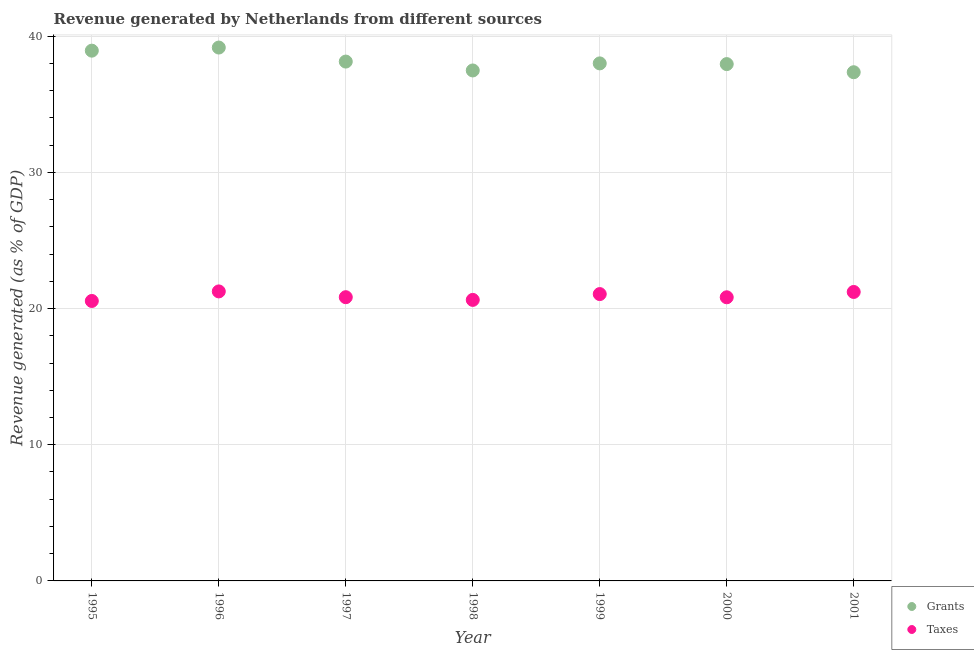Is the number of dotlines equal to the number of legend labels?
Ensure brevity in your answer.  Yes. What is the revenue generated by taxes in 1998?
Your answer should be compact. 20.64. Across all years, what is the maximum revenue generated by grants?
Your response must be concise. 39.17. Across all years, what is the minimum revenue generated by grants?
Keep it short and to the point. 37.36. In which year was the revenue generated by grants maximum?
Offer a very short reply. 1996. In which year was the revenue generated by grants minimum?
Offer a very short reply. 2001. What is the total revenue generated by taxes in the graph?
Offer a terse response. 146.41. What is the difference between the revenue generated by taxes in 1998 and that in 1999?
Ensure brevity in your answer.  -0.43. What is the difference between the revenue generated by grants in 1997 and the revenue generated by taxes in 1998?
Make the answer very short. 17.5. What is the average revenue generated by taxes per year?
Your answer should be compact. 20.92. In the year 1998, what is the difference between the revenue generated by grants and revenue generated by taxes?
Offer a terse response. 16.85. In how many years, is the revenue generated by taxes greater than 10 %?
Offer a very short reply. 7. What is the ratio of the revenue generated by taxes in 1998 to that in 1999?
Offer a very short reply. 0.98. Is the difference between the revenue generated by taxes in 1995 and 2000 greater than the difference between the revenue generated by grants in 1995 and 2000?
Offer a very short reply. No. What is the difference between the highest and the second highest revenue generated by grants?
Your response must be concise. 0.23. What is the difference between the highest and the lowest revenue generated by grants?
Provide a succinct answer. 1.81. Is the sum of the revenue generated by grants in 1998 and 2000 greater than the maximum revenue generated by taxes across all years?
Give a very brief answer. Yes. Does the revenue generated by taxes monotonically increase over the years?
Ensure brevity in your answer.  No. Is the revenue generated by taxes strictly greater than the revenue generated by grants over the years?
Ensure brevity in your answer.  No. Is the revenue generated by grants strictly less than the revenue generated by taxes over the years?
Ensure brevity in your answer.  No. How many dotlines are there?
Offer a very short reply. 2. How many years are there in the graph?
Give a very brief answer. 7. Does the graph contain any zero values?
Offer a terse response. No. Does the graph contain grids?
Your response must be concise. Yes. Where does the legend appear in the graph?
Your answer should be compact. Bottom right. How many legend labels are there?
Ensure brevity in your answer.  2. How are the legend labels stacked?
Offer a terse response. Vertical. What is the title of the graph?
Your answer should be compact. Revenue generated by Netherlands from different sources. Does "Rural Population" appear as one of the legend labels in the graph?
Make the answer very short. No. What is the label or title of the X-axis?
Make the answer very short. Year. What is the label or title of the Y-axis?
Offer a very short reply. Revenue generated (as % of GDP). What is the Revenue generated (as % of GDP) in Grants in 1995?
Your answer should be very brief. 38.94. What is the Revenue generated (as % of GDP) in Taxes in 1995?
Give a very brief answer. 20.56. What is the Revenue generated (as % of GDP) in Grants in 1996?
Keep it short and to the point. 39.17. What is the Revenue generated (as % of GDP) of Taxes in 1996?
Offer a very short reply. 21.26. What is the Revenue generated (as % of GDP) of Grants in 1997?
Give a very brief answer. 38.14. What is the Revenue generated (as % of GDP) in Taxes in 1997?
Ensure brevity in your answer.  20.84. What is the Revenue generated (as % of GDP) in Grants in 1998?
Give a very brief answer. 37.49. What is the Revenue generated (as % of GDP) in Taxes in 1998?
Your answer should be compact. 20.64. What is the Revenue generated (as % of GDP) in Grants in 1999?
Provide a succinct answer. 38.01. What is the Revenue generated (as % of GDP) in Taxes in 1999?
Offer a terse response. 21.07. What is the Revenue generated (as % of GDP) in Grants in 2000?
Your answer should be very brief. 37.95. What is the Revenue generated (as % of GDP) of Taxes in 2000?
Provide a short and direct response. 20.83. What is the Revenue generated (as % of GDP) of Grants in 2001?
Offer a terse response. 37.36. What is the Revenue generated (as % of GDP) of Taxes in 2001?
Make the answer very short. 21.22. Across all years, what is the maximum Revenue generated (as % of GDP) of Grants?
Provide a succinct answer. 39.17. Across all years, what is the maximum Revenue generated (as % of GDP) in Taxes?
Your response must be concise. 21.26. Across all years, what is the minimum Revenue generated (as % of GDP) of Grants?
Keep it short and to the point. 37.36. Across all years, what is the minimum Revenue generated (as % of GDP) of Taxes?
Ensure brevity in your answer.  20.56. What is the total Revenue generated (as % of GDP) of Grants in the graph?
Your answer should be compact. 267.06. What is the total Revenue generated (as % of GDP) in Taxes in the graph?
Provide a short and direct response. 146.41. What is the difference between the Revenue generated (as % of GDP) in Grants in 1995 and that in 1996?
Provide a succinct answer. -0.23. What is the difference between the Revenue generated (as % of GDP) in Taxes in 1995 and that in 1996?
Your answer should be compact. -0.7. What is the difference between the Revenue generated (as % of GDP) in Grants in 1995 and that in 1997?
Keep it short and to the point. 0.8. What is the difference between the Revenue generated (as % of GDP) in Taxes in 1995 and that in 1997?
Provide a succinct answer. -0.28. What is the difference between the Revenue generated (as % of GDP) of Grants in 1995 and that in 1998?
Offer a very short reply. 1.45. What is the difference between the Revenue generated (as % of GDP) in Taxes in 1995 and that in 1998?
Make the answer very short. -0.08. What is the difference between the Revenue generated (as % of GDP) of Grants in 1995 and that in 1999?
Your answer should be very brief. 0.94. What is the difference between the Revenue generated (as % of GDP) in Taxes in 1995 and that in 1999?
Ensure brevity in your answer.  -0.51. What is the difference between the Revenue generated (as % of GDP) of Grants in 1995 and that in 2000?
Provide a short and direct response. 0.99. What is the difference between the Revenue generated (as % of GDP) of Taxes in 1995 and that in 2000?
Your response must be concise. -0.27. What is the difference between the Revenue generated (as % of GDP) in Grants in 1995 and that in 2001?
Provide a short and direct response. 1.58. What is the difference between the Revenue generated (as % of GDP) of Taxes in 1995 and that in 2001?
Your answer should be compact. -0.66. What is the difference between the Revenue generated (as % of GDP) in Grants in 1996 and that in 1997?
Provide a short and direct response. 1.03. What is the difference between the Revenue generated (as % of GDP) of Taxes in 1996 and that in 1997?
Provide a short and direct response. 0.42. What is the difference between the Revenue generated (as % of GDP) of Grants in 1996 and that in 1998?
Make the answer very short. 1.68. What is the difference between the Revenue generated (as % of GDP) of Taxes in 1996 and that in 1998?
Offer a very short reply. 0.62. What is the difference between the Revenue generated (as % of GDP) in Grants in 1996 and that in 1999?
Provide a short and direct response. 1.16. What is the difference between the Revenue generated (as % of GDP) of Taxes in 1996 and that in 1999?
Provide a short and direct response. 0.2. What is the difference between the Revenue generated (as % of GDP) in Grants in 1996 and that in 2000?
Give a very brief answer. 1.22. What is the difference between the Revenue generated (as % of GDP) in Taxes in 1996 and that in 2000?
Provide a short and direct response. 0.43. What is the difference between the Revenue generated (as % of GDP) of Grants in 1996 and that in 2001?
Keep it short and to the point. 1.81. What is the difference between the Revenue generated (as % of GDP) of Taxes in 1996 and that in 2001?
Your answer should be very brief. 0.04. What is the difference between the Revenue generated (as % of GDP) in Grants in 1997 and that in 1998?
Give a very brief answer. 0.65. What is the difference between the Revenue generated (as % of GDP) of Taxes in 1997 and that in 1998?
Provide a succinct answer. 0.2. What is the difference between the Revenue generated (as % of GDP) of Grants in 1997 and that in 1999?
Your response must be concise. 0.13. What is the difference between the Revenue generated (as % of GDP) in Taxes in 1997 and that in 1999?
Your answer should be very brief. -0.23. What is the difference between the Revenue generated (as % of GDP) in Grants in 1997 and that in 2000?
Your answer should be very brief. 0.19. What is the difference between the Revenue generated (as % of GDP) of Taxes in 1997 and that in 2000?
Provide a short and direct response. 0.01. What is the difference between the Revenue generated (as % of GDP) of Grants in 1997 and that in 2001?
Give a very brief answer. 0.78. What is the difference between the Revenue generated (as % of GDP) of Taxes in 1997 and that in 2001?
Provide a short and direct response. -0.38. What is the difference between the Revenue generated (as % of GDP) in Grants in 1998 and that in 1999?
Provide a short and direct response. -0.52. What is the difference between the Revenue generated (as % of GDP) in Taxes in 1998 and that in 1999?
Keep it short and to the point. -0.43. What is the difference between the Revenue generated (as % of GDP) of Grants in 1998 and that in 2000?
Your answer should be compact. -0.47. What is the difference between the Revenue generated (as % of GDP) of Taxes in 1998 and that in 2000?
Make the answer very short. -0.19. What is the difference between the Revenue generated (as % of GDP) in Grants in 1998 and that in 2001?
Your response must be concise. 0.13. What is the difference between the Revenue generated (as % of GDP) of Taxes in 1998 and that in 2001?
Keep it short and to the point. -0.58. What is the difference between the Revenue generated (as % of GDP) of Grants in 1999 and that in 2000?
Provide a short and direct response. 0.05. What is the difference between the Revenue generated (as % of GDP) of Taxes in 1999 and that in 2000?
Give a very brief answer. 0.24. What is the difference between the Revenue generated (as % of GDP) of Grants in 1999 and that in 2001?
Provide a short and direct response. 0.65. What is the difference between the Revenue generated (as % of GDP) of Taxes in 1999 and that in 2001?
Make the answer very short. -0.16. What is the difference between the Revenue generated (as % of GDP) of Grants in 2000 and that in 2001?
Make the answer very short. 0.6. What is the difference between the Revenue generated (as % of GDP) in Taxes in 2000 and that in 2001?
Ensure brevity in your answer.  -0.39. What is the difference between the Revenue generated (as % of GDP) of Grants in 1995 and the Revenue generated (as % of GDP) of Taxes in 1996?
Your answer should be compact. 17.68. What is the difference between the Revenue generated (as % of GDP) of Grants in 1995 and the Revenue generated (as % of GDP) of Taxes in 1997?
Offer a very short reply. 18.11. What is the difference between the Revenue generated (as % of GDP) in Grants in 1995 and the Revenue generated (as % of GDP) in Taxes in 1998?
Make the answer very short. 18.3. What is the difference between the Revenue generated (as % of GDP) of Grants in 1995 and the Revenue generated (as % of GDP) of Taxes in 1999?
Ensure brevity in your answer.  17.88. What is the difference between the Revenue generated (as % of GDP) in Grants in 1995 and the Revenue generated (as % of GDP) in Taxes in 2000?
Give a very brief answer. 18.11. What is the difference between the Revenue generated (as % of GDP) of Grants in 1995 and the Revenue generated (as % of GDP) of Taxes in 2001?
Your response must be concise. 17.72. What is the difference between the Revenue generated (as % of GDP) in Grants in 1996 and the Revenue generated (as % of GDP) in Taxes in 1997?
Make the answer very short. 18.33. What is the difference between the Revenue generated (as % of GDP) in Grants in 1996 and the Revenue generated (as % of GDP) in Taxes in 1998?
Provide a short and direct response. 18.53. What is the difference between the Revenue generated (as % of GDP) in Grants in 1996 and the Revenue generated (as % of GDP) in Taxes in 1999?
Provide a succinct answer. 18.1. What is the difference between the Revenue generated (as % of GDP) of Grants in 1996 and the Revenue generated (as % of GDP) of Taxes in 2000?
Offer a terse response. 18.34. What is the difference between the Revenue generated (as % of GDP) in Grants in 1996 and the Revenue generated (as % of GDP) in Taxes in 2001?
Give a very brief answer. 17.95. What is the difference between the Revenue generated (as % of GDP) in Grants in 1997 and the Revenue generated (as % of GDP) in Taxes in 1998?
Your answer should be compact. 17.5. What is the difference between the Revenue generated (as % of GDP) of Grants in 1997 and the Revenue generated (as % of GDP) of Taxes in 1999?
Give a very brief answer. 17.07. What is the difference between the Revenue generated (as % of GDP) in Grants in 1997 and the Revenue generated (as % of GDP) in Taxes in 2000?
Offer a terse response. 17.31. What is the difference between the Revenue generated (as % of GDP) in Grants in 1997 and the Revenue generated (as % of GDP) in Taxes in 2001?
Your answer should be compact. 16.92. What is the difference between the Revenue generated (as % of GDP) in Grants in 1998 and the Revenue generated (as % of GDP) in Taxes in 1999?
Give a very brief answer. 16.42. What is the difference between the Revenue generated (as % of GDP) in Grants in 1998 and the Revenue generated (as % of GDP) in Taxes in 2000?
Your answer should be very brief. 16.66. What is the difference between the Revenue generated (as % of GDP) in Grants in 1998 and the Revenue generated (as % of GDP) in Taxes in 2001?
Offer a very short reply. 16.27. What is the difference between the Revenue generated (as % of GDP) in Grants in 1999 and the Revenue generated (as % of GDP) in Taxes in 2000?
Make the answer very short. 17.18. What is the difference between the Revenue generated (as % of GDP) in Grants in 1999 and the Revenue generated (as % of GDP) in Taxes in 2001?
Your answer should be compact. 16.79. What is the difference between the Revenue generated (as % of GDP) of Grants in 2000 and the Revenue generated (as % of GDP) of Taxes in 2001?
Offer a terse response. 16.73. What is the average Revenue generated (as % of GDP) in Grants per year?
Your answer should be compact. 38.15. What is the average Revenue generated (as % of GDP) in Taxes per year?
Your answer should be compact. 20.92. In the year 1995, what is the difference between the Revenue generated (as % of GDP) in Grants and Revenue generated (as % of GDP) in Taxes?
Ensure brevity in your answer.  18.38. In the year 1996, what is the difference between the Revenue generated (as % of GDP) in Grants and Revenue generated (as % of GDP) in Taxes?
Your answer should be compact. 17.91. In the year 1997, what is the difference between the Revenue generated (as % of GDP) of Grants and Revenue generated (as % of GDP) of Taxes?
Your answer should be compact. 17.3. In the year 1998, what is the difference between the Revenue generated (as % of GDP) in Grants and Revenue generated (as % of GDP) in Taxes?
Offer a very short reply. 16.85. In the year 1999, what is the difference between the Revenue generated (as % of GDP) in Grants and Revenue generated (as % of GDP) in Taxes?
Your answer should be compact. 16.94. In the year 2000, what is the difference between the Revenue generated (as % of GDP) of Grants and Revenue generated (as % of GDP) of Taxes?
Keep it short and to the point. 17.12. In the year 2001, what is the difference between the Revenue generated (as % of GDP) in Grants and Revenue generated (as % of GDP) in Taxes?
Keep it short and to the point. 16.14. What is the ratio of the Revenue generated (as % of GDP) in Taxes in 1995 to that in 1996?
Keep it short and to the point. 0.97. What is the ratio of the Revenue generated (as % of GDP) of Taxes in 1995 to that in 1997?
Ensure brevity in your answer.  0.99. What is the ratio of the Revenue generated (as % of GDP) of Grants in 1995 to that in 1998?
Make the answer very short. 1.04. What is the ratio of the Revenue generated (as % of GDP) in Taxes in 1995 to that in 1998?
Make the answer very short. 1. What is the ratio of the Revenue generated (as % of GDP) in Grants in 1995 to that in 1999?
Make the answer very short. 1.02. What is the ratio of the Revenue generated (as % of GDP) in Grants in 1995 to that in 2000?
Ensure brevity in your answer.  1.03. What is the ratio of the Revenue generated (as % of GDP) of Grants in 1995 to that in 2001?
Give a very brief answer. 1.04. What is the ratio of the Revenue generated (as % of GDP) in Taxes in 1995 to that in 2001?
Ensure brevity in your answer.  0.97. What is the ratio of the Revenue generated (as % of GDP) of Taxes in 1996 to that in 1997?
Give a very brief answer. 1.02. What is the ratio of the Revenue generated (as % of GDP) in Grants in 1996 to that in 1998?
Your answer should be very brief. 1.04. What is the ratio of the Revenue generated (as % of GDP) of Taxes in 1996 to that in 1998?
Ensure brevity in your answer.  1.03. What is the ratio of the Revenue generated (as % of GDP) of Grants in 1996 to that in 1999?
Make the answer very short. 1.03. What is the ratio of the Revenue generated (as % of GDP) of Taxes in 1996 to that in 1999?
Offer a terse response. 1.01. What is the ratio of the Revenue generated (as % of GDP) in Grants in 1996 to that in 2000?
Keep it short and to the point. 1.03. What is the ratio of the Revenue generated (as % of GDP) in Taxes in 1996 to that in 2000?
Make the answer very short. 1.02. What is the ratio of the Revenue generated (as % of GDP) in Grants in 1996 to that in 2001?
Ensure brevity in your answer.  1.05. What is the ratio of the Revenue generated (as % of GDP) in Taxes in 1996 to that in 2001?
Provide a short and direct response. 1. What is the ratio of the Revenue generated (as % of GDP) of Grants in 1997 to that in 1998?
Your response must be concise. 1.02. What is the ratio of the Revenue generated (as % of GDP) in Taxes in 1997 to that in 1998?
Keep it short and to the point. 1.01. What is the ratio of the Revenue generated (as % of GDP) of Grants in 1997 to that in 1999?
Keep it short and to the point. 1. What is the ratio of the Revenue generated (as % of GDP) of Taxes in 1997 to that in 1999?
Provide a succinct answer. 0.99. What is the ratio of the Revenue generated (as % of GDP) in Grants in 1997 to that in 2000?
Offer a terse response. 1. What is the ratio of the Revenue generated (as % of GDP) of Grants in 1997 to that in 2001?
Your answer should be compact. 1.02. What is the ratio of the Revenue generated (as % of GDP) of Taxes in 1997 to that in 2001?
Offer a very short reply. 0.98. What is the ratio of the Revenue generated (as % of GDP) in Grants in 1998 to that in 1999?
Provide a succinct answer. 0.99. What is the ratio of the Revenue generated (as % of GDP) of Taxes in 1998 to that in 1999?
Offer a very short reply. 0.98. What is the ratio of the Revenue generated (as % of GDP) in Taxes in 1998 to that in 2001?
Your answer should be very brief. 0.97. What is the ratio of the Revenue generated (as % of GDP) in Grants in 1999 to that in 2000?
Give a very brief answer. 1. What is the ratio of the Revenue generated (as % of GDP) in Taxes in 1999 to that in 2000?
Keep it short and to the point. 1.01. What is the ratio of the Revenue generated (as % of GDP) of Grants in 1999 to that in 2001?
Your response must be concise. 1.02. What is the ratio of the Revenue generated (as % of GDP) in Grants in 2000 to that in 2001?
Your answer should be very brief. 1.02. What is the ratio of the Revenue generated (as % of GDP) of Taxes in 2000 to that in 2001?
Your answer should be very brief. 0.98. What is the difference between the highest and the second highest Revenue generated (as % of GDP) of Grants?
Offer a very short reply. 0.23. What is the difference between the highest and the second highest Revenue generated (as % of GDP) in Taxes?
Offer a very short reply. 0.04. What is the difference between the highest and the lowest Revenue generated (as % of GDP) in Grants?
Keep it short and to the point. 1.81. What is the difference between the highest and the lowest Revenue generated (as % of GDP) of Taxes?
Your answer should be compact. 0.7. 